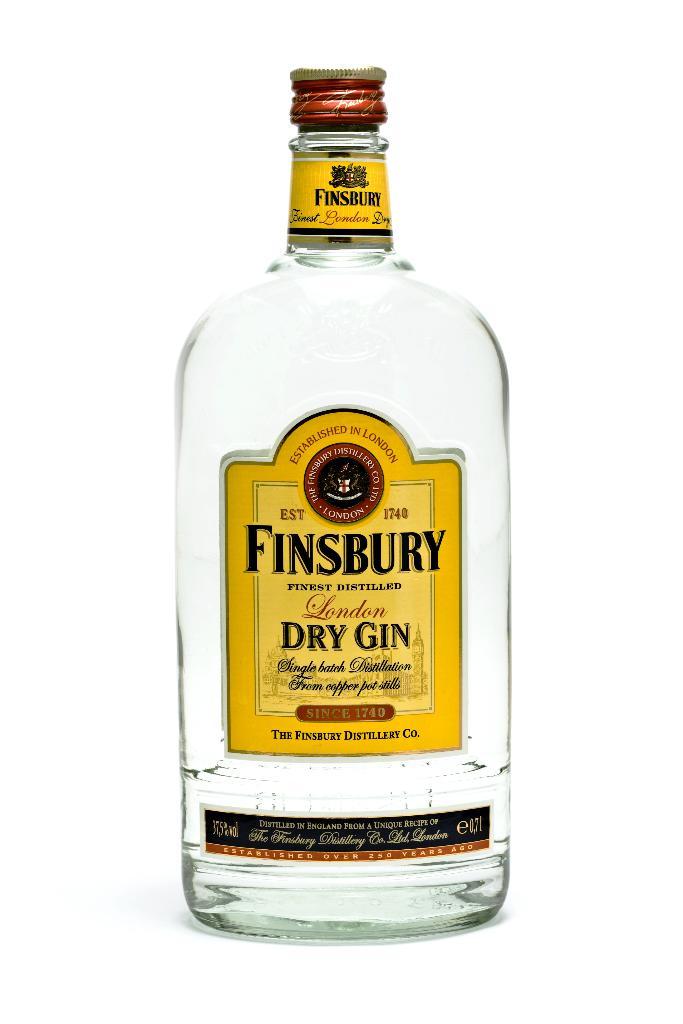What is the type of finsbury gin?
Your answer should be compact. Dry gin. 